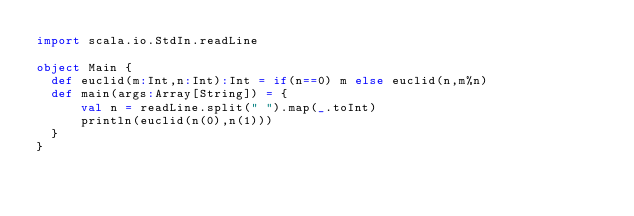Convert code to text. <code><loc_0><loc_0><loc_500><loc_500><_Scala_>import scala.io.StdIn.readLine
 
object Main {
  def euclid(m:Int,n:Int):Int = if(n==0) m else euclid(n,m%n)
  def main(args:Array[String]) = {
      val n = readLine.split(" ").map(_.toInt)
      println(euclid(n(0),n(1)))
  }
}</code> 